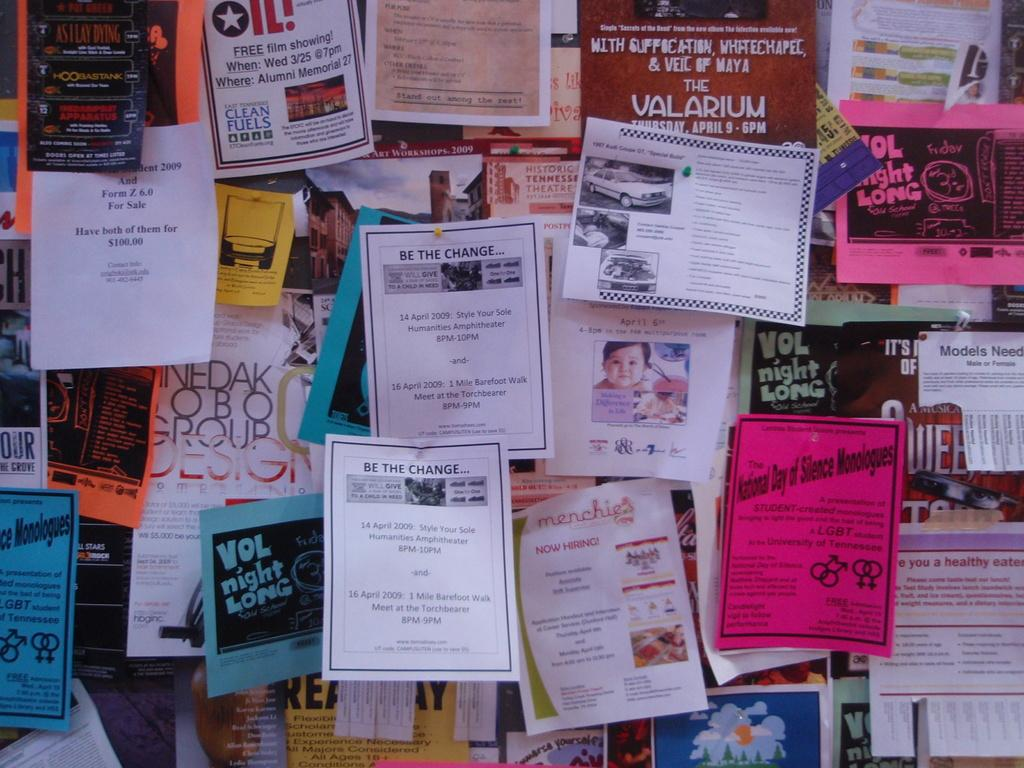<image>
Describe the image concisely. The pamphlet on the board said ,"Be the Change." 